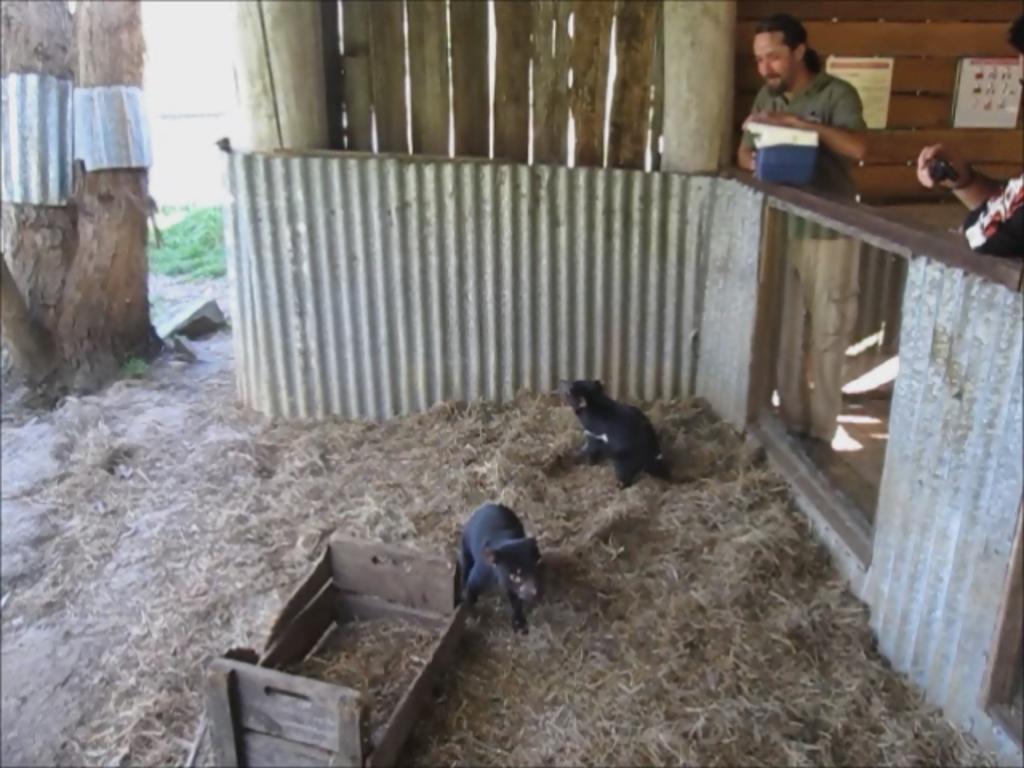How would you summarize this image in a sentence or two? In the center of the image we can see two animals on the ground. To the right side of the image we can see two persons standing on the ground. One person holding a container in his hand. In the background, we can see photo frames on the wall, fence and a tree. 